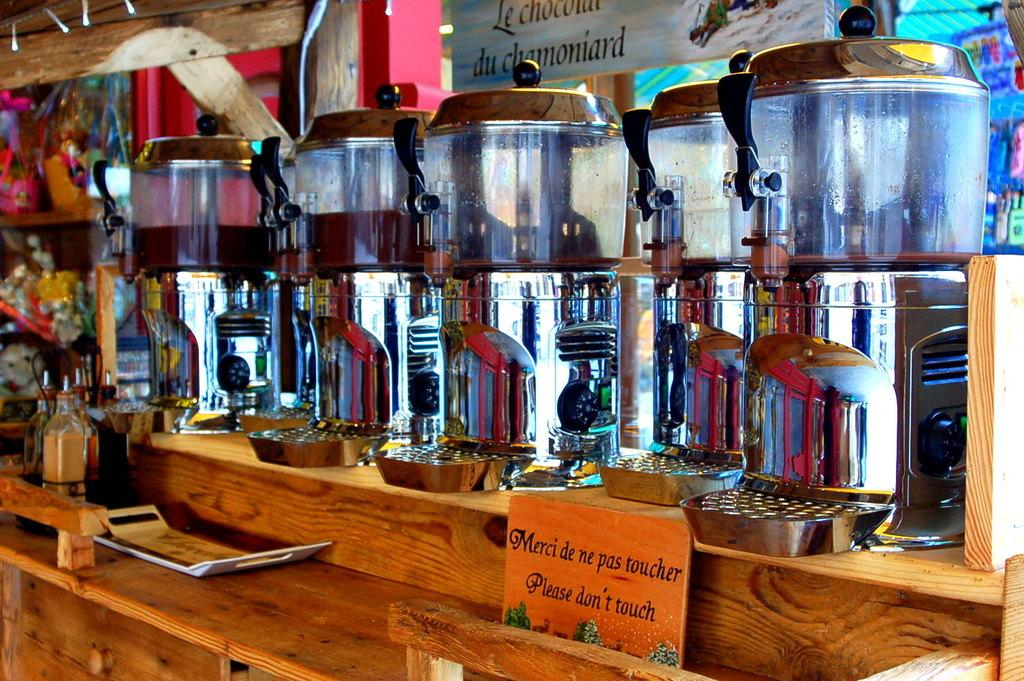<image>
Provide a brief description of the given image. A sign on the counter asks, "Please don't touch". 